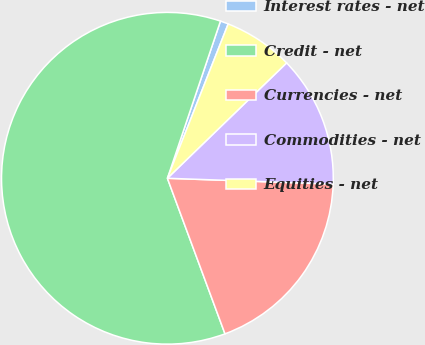Convert chart to OTSL. <chart><loc_0><loc_0><loc_500><loc_500><pie_chart><fcel>Interest rates - net<fcel>Credit - net<fcel>Currencies - net<fcel>Commodities - net<fcel>Equities - net<nl><fcel>0.79%<fcel>60.83%<fcel>18.8%<fcel>12.8%<fcel>6.79%<nl></chart> 